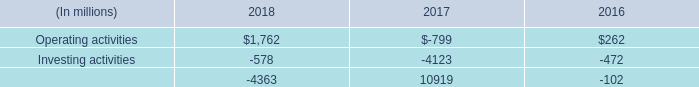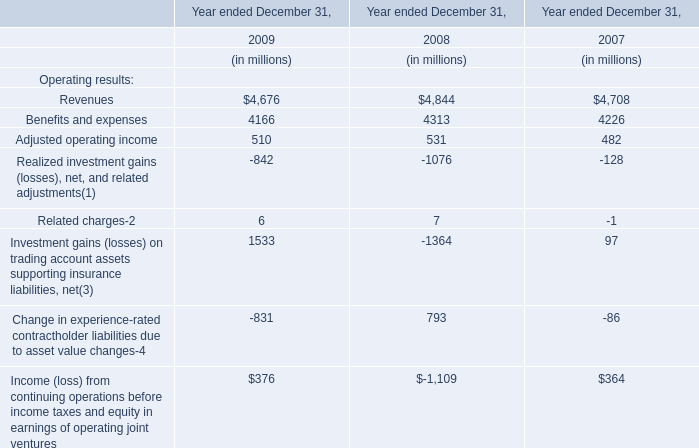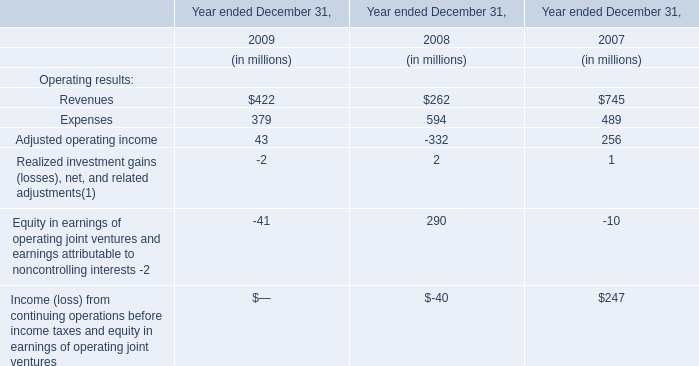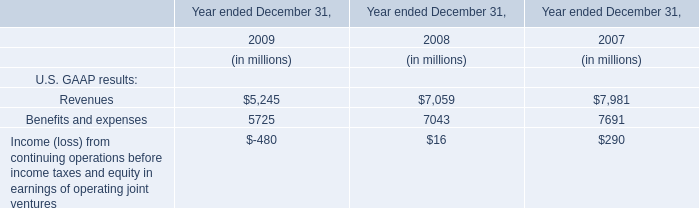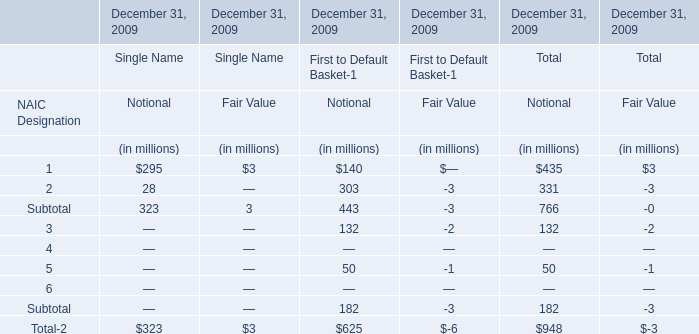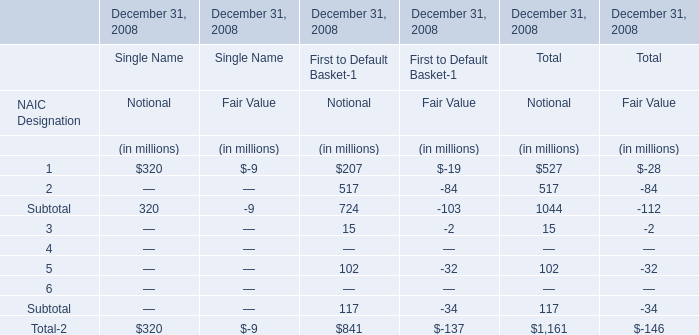what is the net change in cash during 2017? 
Computations: ((-799 + -4123) + 10919)
Answer: 5997.0. 